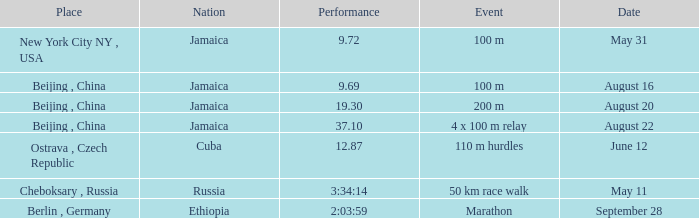Which nation ran a time of 9.69 seconds? Jamaica. 